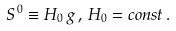<formula> <loc_0><loc_0><loc_500><loc_500>S ^ { \, 0 } \equiv H _ { 0 } \, g \, , \, H _ { 0 } = c o n s t \, .</formula> 